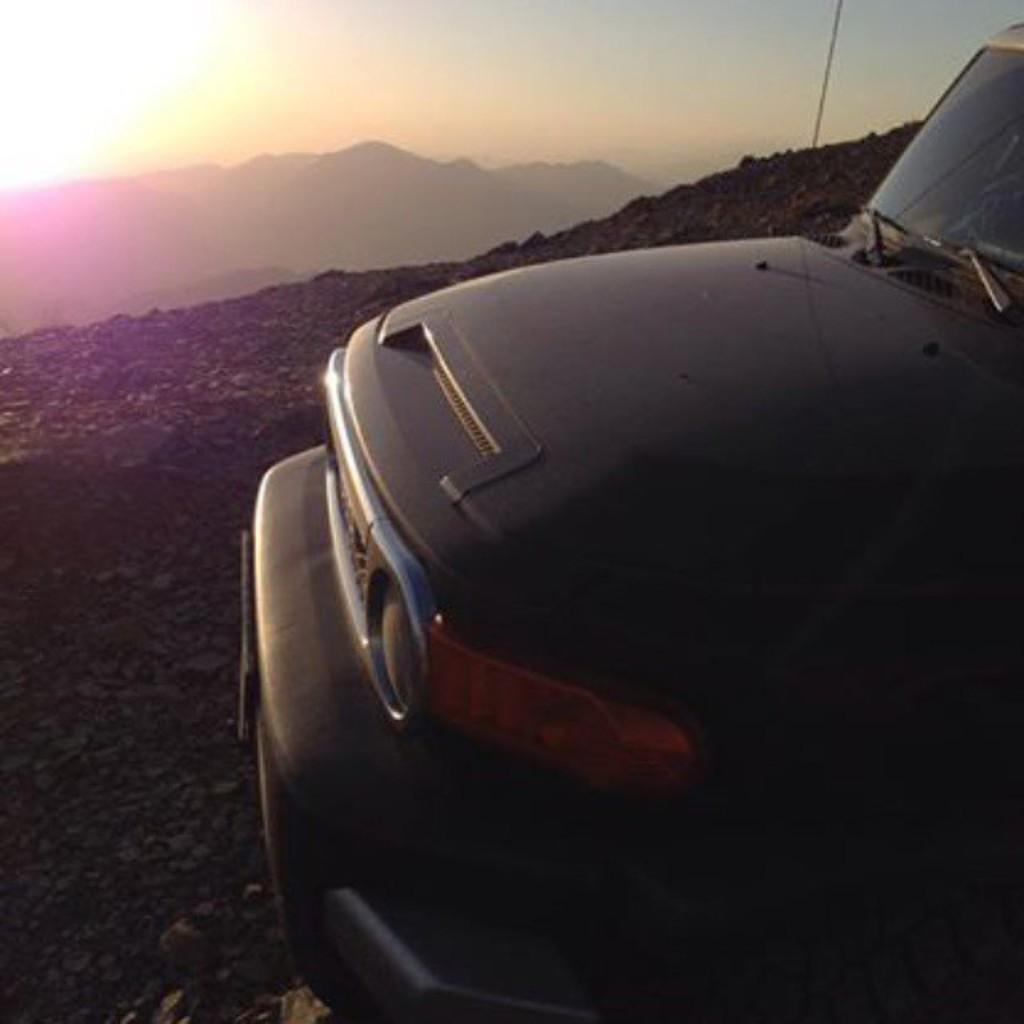What is the main subject of the image? There is a vehicle in the image. What type of terrain is visible in the image? There are stones and mountains in the image. What is visible in the sky in the image? The sky is visible in the image, and the sun is observable. Can you see a rose growing near the vehicle in the image? There is no rose visible in the image. Is there a rabbit hopping around the vehicle in the image? There is no rabbit present in the image. 